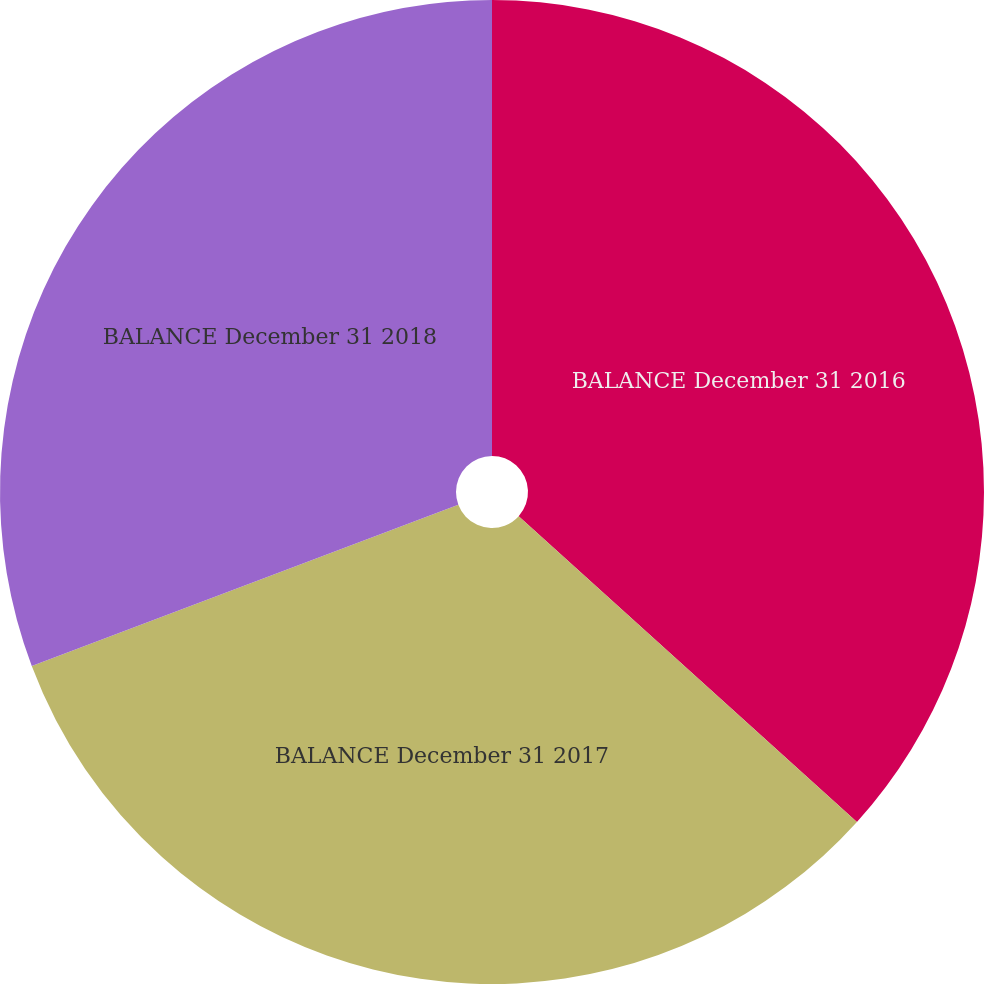Convert chart to OTSL. <chart><loc_0><loc_0><loc_500><loc_500><pie_chart><fcel>BALANCE December 31 2016<fcel>BALANCE December 31 2017<fcel>BALANCE December 31 2018<nl><fcel>36.7%<fcel>32.55%<fcel>30.75%<nl></chart> 